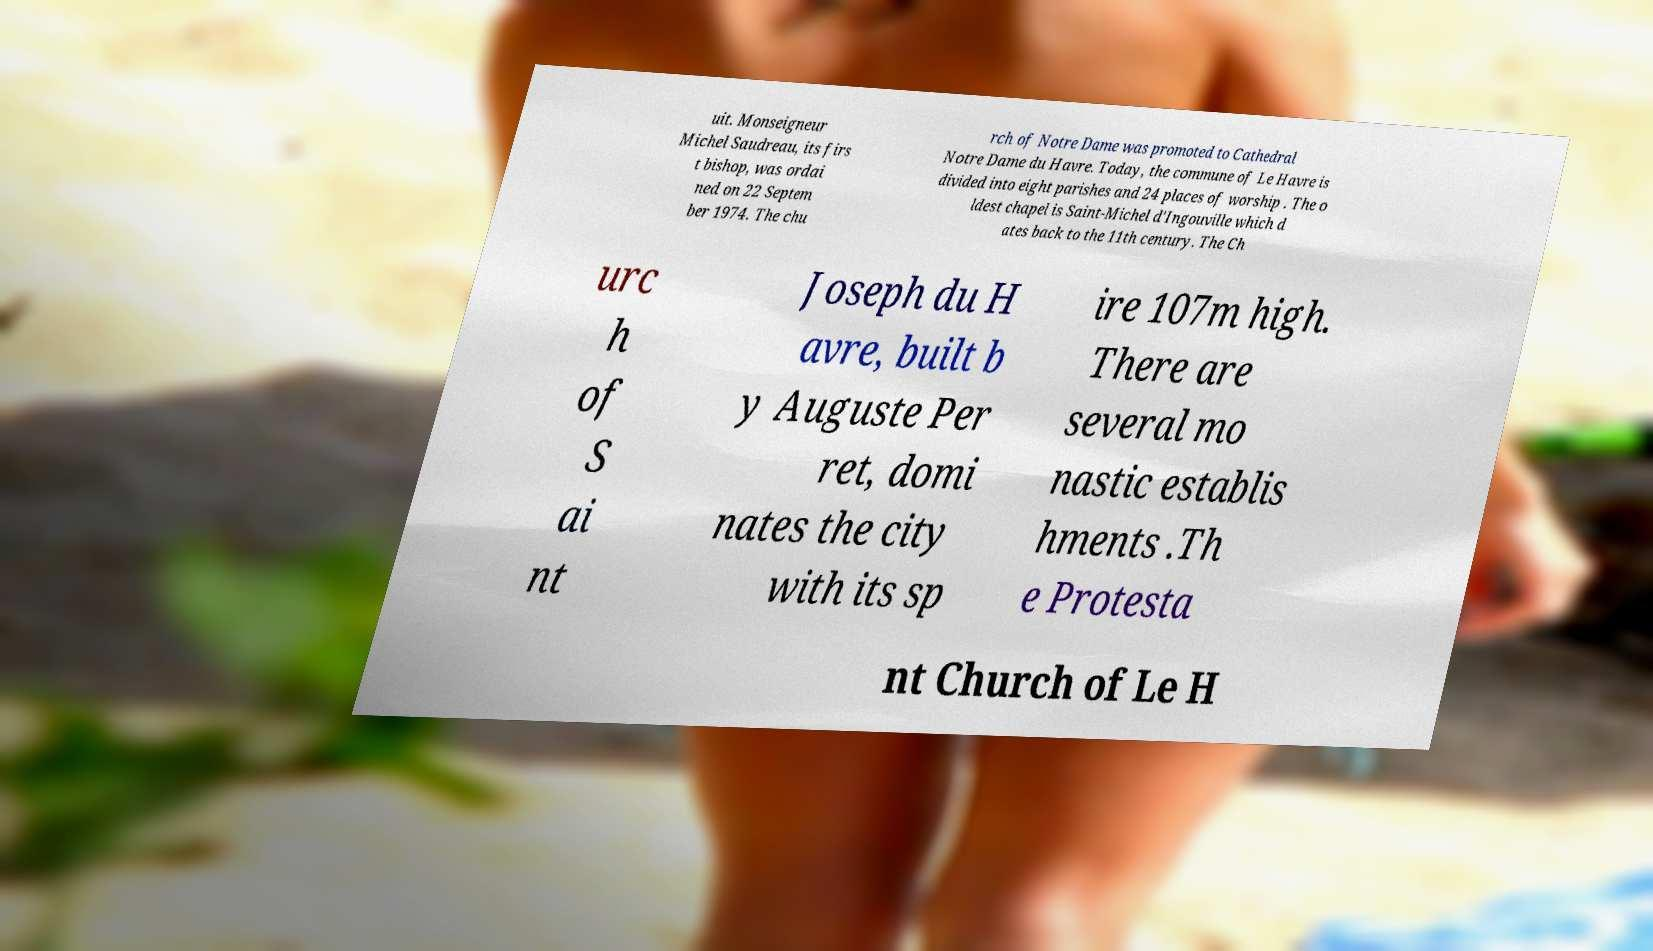What messages or text are displayed in this image? I need them in a readable, typed format. uit. Monseigneur Michel Saudreau, its firs t bishop, was ordai ned on 22 Septem ber 1974. The chu rch of Notre Dame was promoted to Cathedral Notre Dame du Havre. Today, the commune of Le Havre is divided into eight parishes and 24 places of worship . The o ldest chapel is Saint-Michel d'Ingouville which d ates back to the 11th century. The Ch urc h of S ai nt Joseph du H avre, built b y Auguste Per ret, domi nates the city with its sp ire 107m high. There are several mo nastic establis hments .Th e Protesta nt Church of Le H 